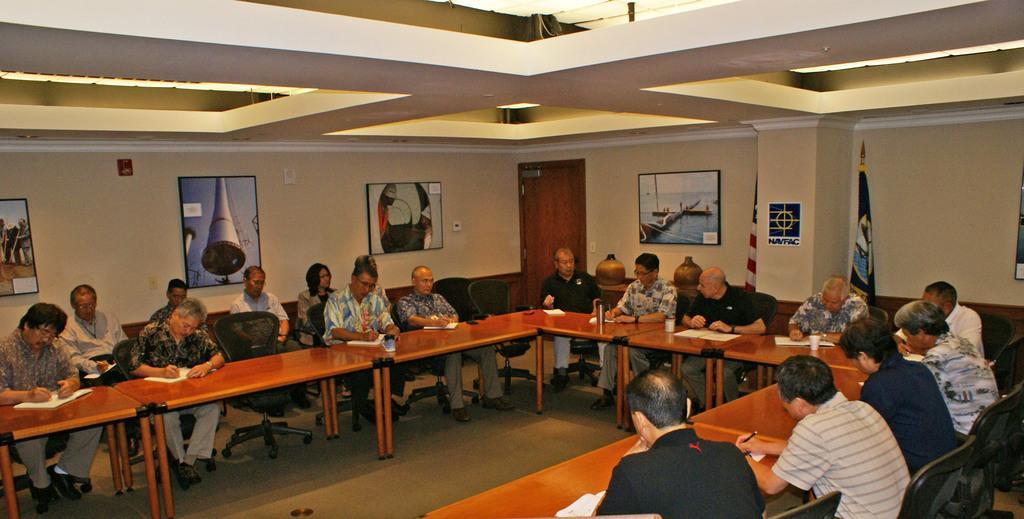How would you summarize this image in a sentence or two? There are many people sitting on chairs. There are many tables. On the tables there are books glasses. Some people are writing on the books. In the background there are wall. On the wall there are many photo frames. Notice pasted on the wall. There is a door. And there are two flags. 